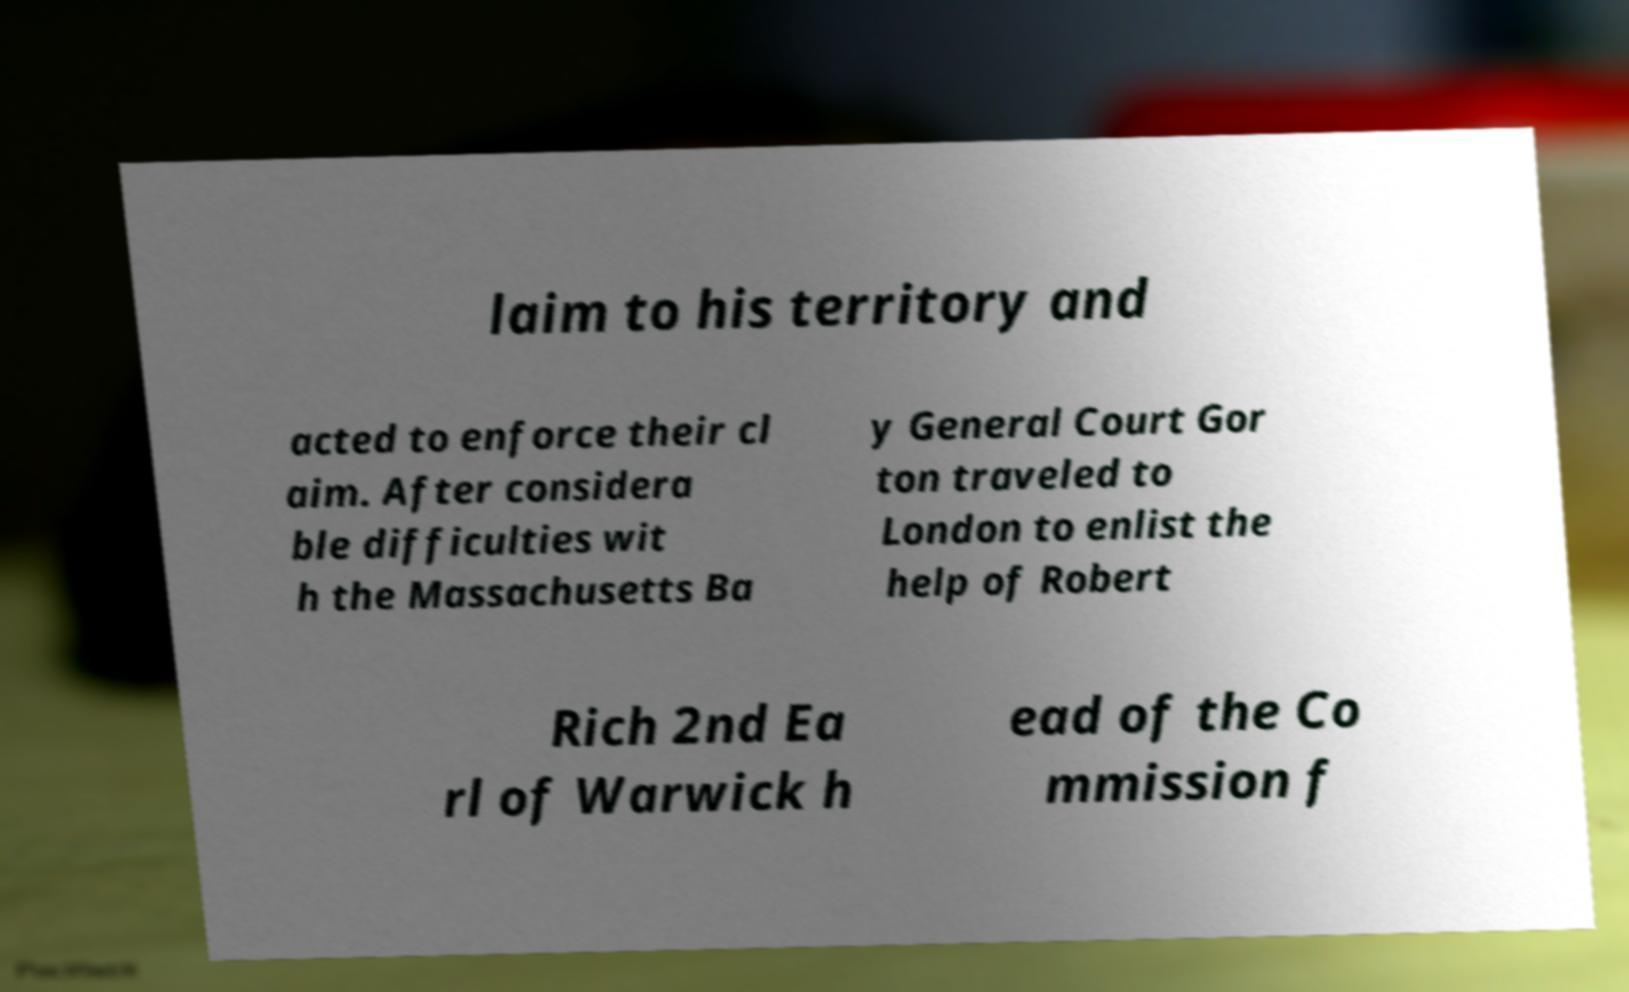Could you extract and type out the text from this image? laim to his territory and acted to enforce their cl aim. After considera ble difficulties wit h the Massachusetts Ba y General Court Gor ton traveled to London to enlist the help of Robert Rich 2nd Ea rl of Warwick h ead of the Co mmission f 